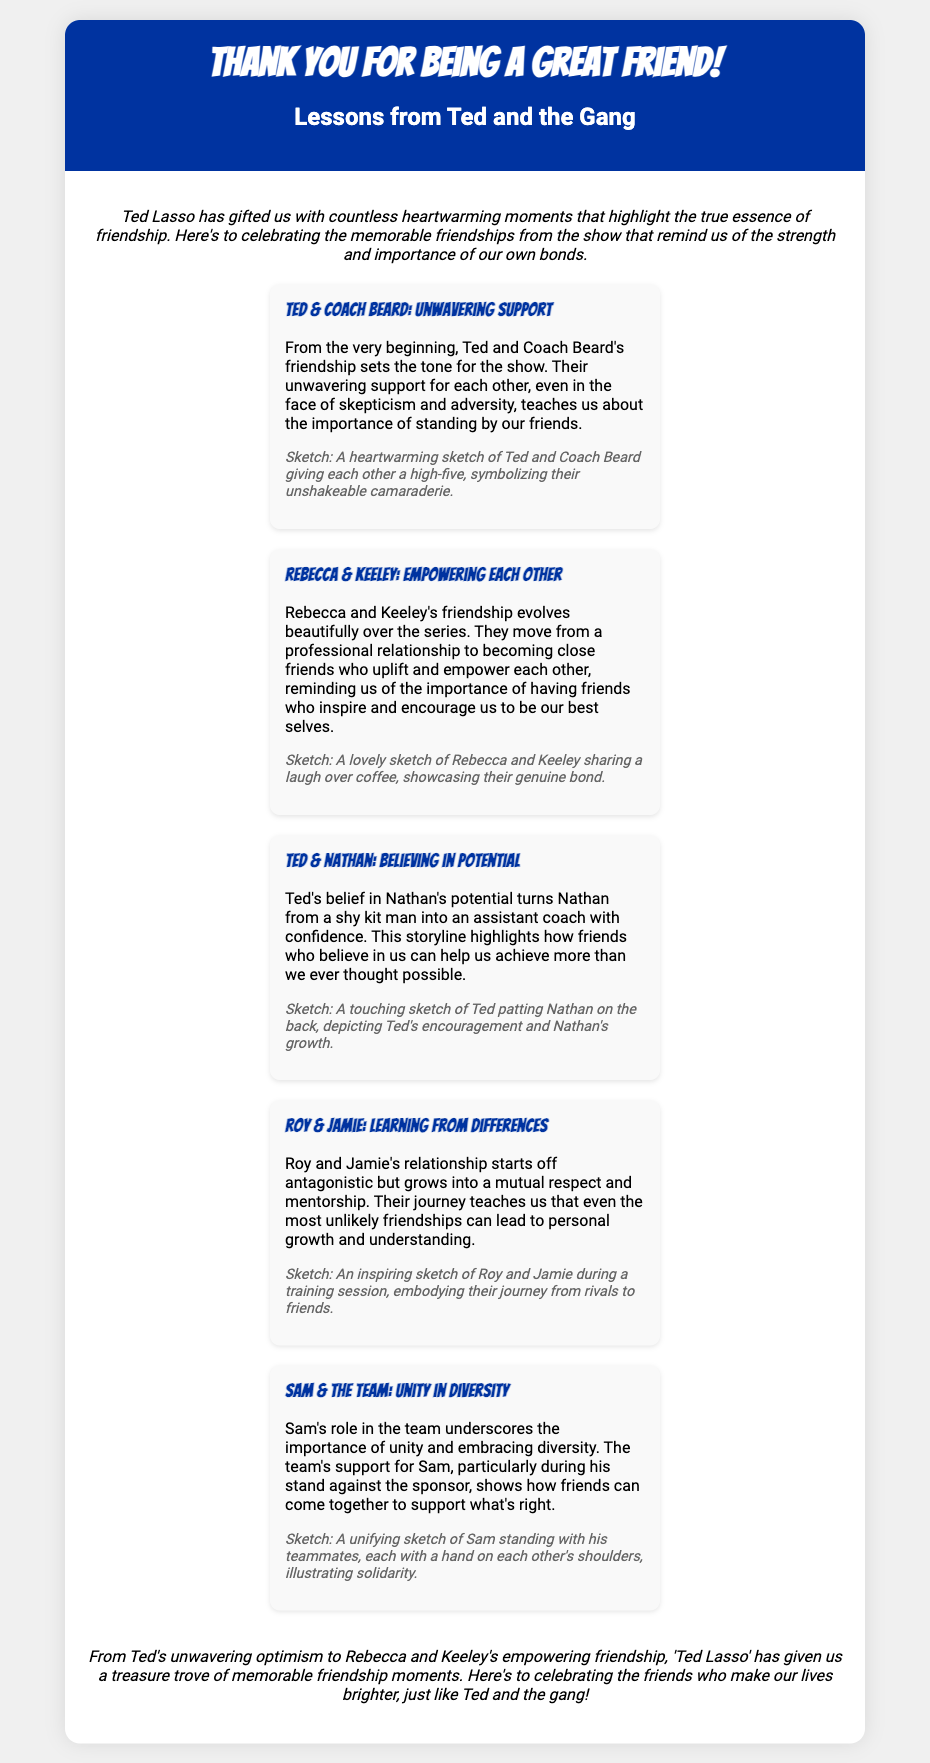What is the title of the card? The title of the card is displayed prominently in the header section.
Answer: Thank You for Being a Great Friend! Who are the main characters highlighted in the friendship lessons? The card features several main characters, each in their own section discussing different friendship lessons.
Answer: Ted, Coach Beard, Rebecca, Keeley, Nathan, Roy, Jamie, Sam How many sections are there detailing friendships? Each section represents a different friendship lesson, and is counted directly in the document.
Answer: Five What emotion is depicted in the sketches accompanying Ted and Coach Beard? The sketch suggests a particular moment and its underlying emotional tone as described.
Answer: High-five What do Rebecca and Keeley empower each other to do? This addresses the main theme of the friendship between Rebecca and Keeley outlined in the document.
Answer: Be their best selves Which character helps Nathan gain confidence? Highlighting the impact of one character on another is a key focus.
Answer: Ted What do Sam and the team symbolize in the context of friendship? This question looks for the overarching theme related to unity in diversity presented in that section.
Answer: Unity What sentiment does the card express in its closing? The closing summarizes the overall message of the card about friendships.
Answer: Celebration of friends 